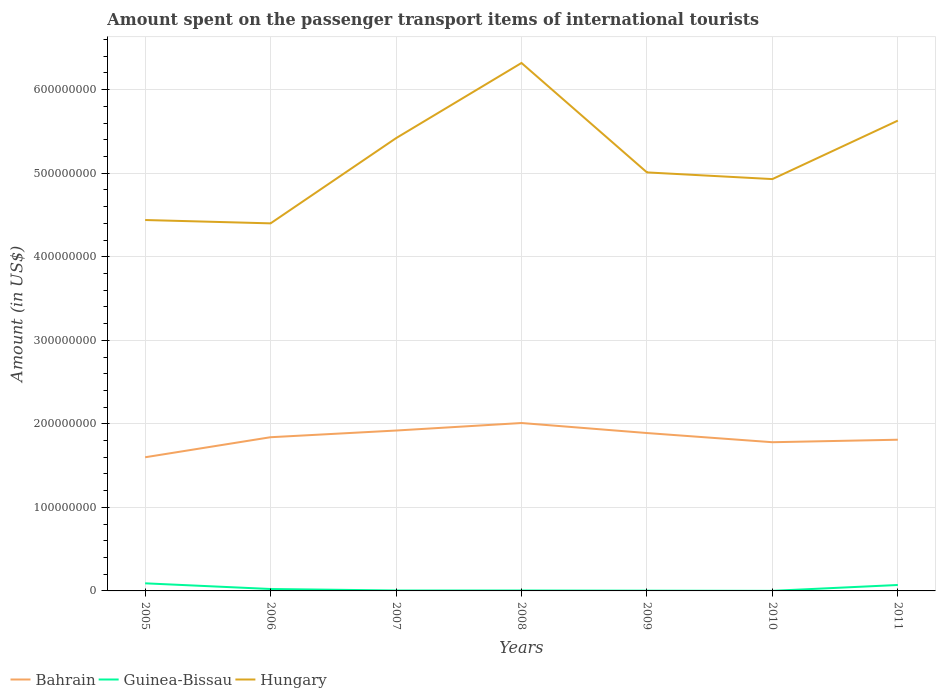How many different coloured lines are there?
Provide a short and direct response. 3. Across all years, what is the maximum amount spent on the passenger transport items of international tourists in Hungary?
Offer a terse response. 4.40e+08. In which year was the amount spent on the passenger transport items of international tourists in Hungary maximum?
Keep it short and to the point. 2006. What is the total amount spent on the passenger transport items of international tourists in Hungary in the graph?
Provide a succinct answer. -4.90e+07. What is the difference between the highest and the second highest amount spent on the passenger transport items of international tourists in Guinea-Bissau?
Provide a short and direct response. 9.00e+06. What is the difference between the highest and the lowest amount spent on the passenger transport items of international tourists in Hungary?
Offer a very short reply. 3. Are the values on the major ticks of Y-axis written in scientific E-notation?
Keep it short and to the point. No. Does the graph contain grids?
Your answer should be very brief. Yes. How many legend labels are there?
Keep it short and to the point. 3. How are the legend labels stacked?
Offer a very short reply. Horizontal. What is the title of the graph?
Provide a short and direct response. Amount spent on the passenger transport items of international tourists. Does "New Caledonia" appear as one of the legend labels in the graph?
Offer a very short reply. No. What is the label or title of the X-axis?
Give a very brief answer. Years. What is the Amount (in US$) of Bahrain in 2005?
Provide a succinct answer. 1.60e+08. What is the Amount (in US$) in Guinea-Bissau in 2005?
Offer a very short reply. 9.10e+06. What is the Amount (in US$) in Hungary in 2005?
Your response must be concise. 4.44e+08. What is the Amount (in US$) in Bahrain in 2006?
Offer a very short reply. 1.84e+08. What is the Amount (in US$) in Guinea-Bissau in 2006?
Your response must be concise. 2.30e+06. What is the Amount (in US$) in Hungary in 2006?
Provide a succinct answer. 4.40e+08. What is the Amount (in US$) in Bahrain in 2007?
Your response must be concise. 1.92e+08. What is the Amount (in US$) in Hungary in 2007?
Offer a very short reply. 5.42e+08. What is the Amount (in US$) in Bahrain in 2008?
Offer a terse response. 2.01e+08. What is the Amount (in US$) in Guinea-Bissau in 2008?
Offer a terse response. 5.00e+05. What is the Amount (in US$) of Hungary in 2008?
Give a very brief answer. 6.32e+08. What is the Amount (in US$) of Bahrain in 2009?
Provide a succinct answer. 1.89e+08. What is the Amount (in US$) in Hungary in 2009?
Your answer should be compact. 5.01e+08. What is the Amount (in US$) of Bahrain in 2010?
Ensure brevity in your answer.  1.78e+08. What is the Amount (in US$) of Guinea-Bissau in 2010?
Ensure brevity in your answer.  1.00e+05. What is the Amount (in US$) in Hungary in 2010?
Provide a succinct answer. 4.93e+08. What is the Amount (in US$) in Bahrain in 2011?
Offer a very short reply. 1.81e+08. What is the Amount (in US$) in Guinea-Bissau in 2011?
Offer a very short reply. 7.10e+06. What is the Amount (in US$) in Hungary in 2011?
Your answer should be compact. 5.63e+08. Across all years, what is the maximum Amount (in US$) in Bahrain?
Your answer should be compact. 2.01e+08. Across all years, what is the maximum Amount (in US$) in Guinea-Bissau?
Your answer should be very brief. 9.10e+06. Across all years, what is the maximum Amount (in US$) in Hungary?
Your answer should be very brief. 6.32e+08. Across all years, what is the minimum Amount (in US$) in Bahrain?
Your answer should be very brief. 1.60e+08. Across all years, what is the minimum Amount (in US$) in Hungary?
Offer a terse response. 4.40e+08. What is the total Amount (in US$) in Bahrain in the graph?
Offer a very short reply. 1.28e+09. What is the total Amount (in US$) of Guinea-Bissau in the graph?
Offer a very short reply. 1.99e+07. What is the total Amount (in US$) of Hungary in the graph?
Keep it short and to the point. 3.62e+09. What is the difference between the Amount (in US$) in Bahrain in 2005 and that in 2006?
Ensure brevity in your answer.  -2.40e+07. What is the difference between the Amount (in US$) of Guinea-Bissau in 2005 and that in 2006?
Keep it short and to the point. 6.80e+06. What is the difference between the Amount (in US$) of Hungary in 2005 and that in 2006?
Ensure brevity in your answer.  4.00e+06. What is the difference between the Amount (in US$) of Bahrain in 2005 and that in 2007?
Make the answer very short. -3.20e+07. What is the difference between the Amount (in US$) in Guinea-Bissau in 2005 and that in 2007?
Offer a very short reply. 8.60e+06. What is the difference between the Amount (in US$) in Hungary in 2005 and that in 2007?
Make the answer very short. -9.80e+07. What is the difference between the Amount (in US$) of Bahrain in 2005 and that in 2008?
Ensure brevity in your answer.  -4.10e+07. What is the difference between the Amount (in US$) of Guinea-Bissau in 2005 and that in 2008?
Offer a very short reply. 8.60e+06. What is the difference between the Amount (in US$) in Hungary in 2005 and that in 2008?
Keep it short and to the point. -1.88e+08. What is the difference between the Amount (in US$) in Bahrain in 2005 and that in 2009?
Ensure brevity in your answer.  -2.90e+07. What is the difference between the Amount (in US$) of Guinea-Bissau in 2005 and that in 2009?
Offer a terse response. 8.80e+06. What is the difference between the Amount (in US$) in Hungary in 2005 and that in 2009?
Provide a short and direct response. -5.70e+07. What is the difference between the Amount (in US$) of Bahrain in 2005 and that in 2010?
Your answer should be very brief. -1.80e+07. What is the difference between the Amount (in US$) of Guinea-Bissau in 2005 and that in 2010?
Your response must be concise. 9.00e+06. What is the difference between the Amount (in US$) of Hungary in 2005 and that in 2010?
Provide a succinct answer. -4.90e+07. What is the difference between the Amount (in US$) in Bahrain in 2005 and that in 2011?
Ensure brevity in your answer.  -2.10e+07. What is the difference between the Amount (in US$) of Hungary in 2005 and that in 2011?
Keep it short and to the point. -1.19e+08. What is the difference between the Amount (in US$) in Bahrain in 2006 and that in 2007?
Offer a very short reply. -8.00e+06. What is the difference between the Amount (in US$) in Guinea-Bissau in 2006 and that in 2007?
Your answer should be compact. 1.80e+06. What is the difference between the Amount (in US$) in Hungary in 2006 and that in 2007?
Provide a short and direct response. -1.02e+08. What is the difference between the Amount (in US$) in Bahrain in 2006 and that in 2008?
Offer a terse response. -1.70e+07. What is the difference between the Amount (in US$) in Guinea-Bissau in 2006 and that in 2008?
Offer a very short reply. 1.80e+06. What is the difference between the Amount (in US$) of Hungary in 2006 and that in 2008?
Provide a succinct answer. -1.92e+08. What is the difference between the Amount (in US$) of Bahrain in 2006 and that in 2009?
Offer a very short reply. -5.00e+06. What is the difference between the Amount (in US$) of Guinea-Bissau in 2006 and that in 2009?
Give a very brief answer. 2.00e+06. What is the difference between the Amount (in US$) of Hungary in 2006 and that in 2009?
Offer a terse response. -6.10e+07. What is the difference between the Amount (in US$) of Bahrain in 2006 and that in 2010?
Keep it short and to the point. 6.00e+06. What is the difference between the Amount (in US$) in Guinea-Bissau in 2006 and that in 2010?
Provide a short and direct response. 2.20e+06. What is the difference between the Amount (in US$) in Hungary in 2006 and that in 2010?
Make the answer very short. -5.30e+07. What is the difference between the Amount (in US$) in Bahrain in 2006 and that in 2011?
Make the answer very short. 3.00e+06. What is the difference between the Amount (in US$) of Guinea-Bissau in 2006 and that in 2011?
Ensure brevity in your answer.  -4.80e+06. What is the difference between the Amount (in US$) in Hungary in 2006 and that in 2011?
Your answer should be compact. -1.23e+08. What is the difference between the Amount (in US$) in Bahrain in 2007 and that in 2008?
Your response must be concise. -9.00e+06. What is the difference between the Amount (in US$) of Hungary in 2007 and that in 2008?
Your answer should be compact. -9.00e+07. What is the difference between the Amount (in US$) of Guinea-Bissau in 2007 and that in 2009?
Keep it short and to the point. 2.00e+05. What is the difference between the Amount (in US$) in Hungary in 2007 and that in 2009?
Your answer should be very brief. 4.10e+07. What is the difference between the Amount (in US$) in Bahrain in 2007 and that in 2010?
Offer a very short reply. 1.40e+07. What is the difference between the Amount (in US$) of Hungary in 2007 and that in 2010?
Make the answer very short. 4.90e+07. What is the difference between the Amount (in US$) of Bahrain in 2007 and that in 2011?
Give a very brief answer. 1.10e+07. What is the difference between the Amount (in US$) of Guinea-Bissau in 2007 and that in 2011?
Provide a succinct answer. -6.60e+06. What is the difference between the Amount (in US$) in Hungary in 2007 and that in 2011?
Your response must be concise. -2.10e+07. What is the difference between the Amount (in US$) in Guinea-Bissau in 2008 and that in 2009?
Your answer should be very brief. 2.00e+05. What is the difference between the Amount (in US$) in Hungary in 2008 and that in 2009?
Offer a terse response. 1.31e+08. What is the difference between the Amount (in US$) of Bahrain in 2008 and that in 2010?
Offer a very short reply. 2.30e+07. What is the difference between the Amount (in US$) of Guinea-Bissau in 2008 and that in 2010?
Ensure brevity in your answer.  4.00e+05. What is the difference between the Amount (in US$) of Hungary in 2008 and that in 2010?
Your answer should be compact. 1.39e+08. What is the difference between the Amount (in US$) in Guinea-Bissau in 2008 and that in 2011?
Ensure brevity in your answer.  -6.60e+06. What is the difference between the Amount (in US$) in Hungary in 2008 and that in 2011?
Your response must be concise. 6.90e+07. What is the difference between the Amount (in US$) in Bahrain in 2009 and that in 2010?
Keep it short and to the point. 1.10e+07. What is the difference between the Amount (in US$) of Guinea-Bissau in 2009 and that in 2011?
Provide a short and direct response. -6.80e+06. What is the difference between the Amount (in US$) of Hungary in 2009 and that in 2011?
Offer a very short reply. -6.20e+07. What is the difference between the Amount (in US$) of Bahrain in 2010 and that in 2011?
Your response must be concise. -3.00e+06. What is the difference between the Amount (in US$) in Guinea-Bissau in 2010 and that in 2011?
Your answer should be compact. -7.00e+06. What is the difference between the Amount (in US$) in Hungary in 2010 and that in 2011?
Offer a very short reply. -7.00e+07. What is the difference between the Amount (in US$) in Bahrain in 2005 and the Amount (in US$) in Guinea-Bissau in 2006?
Your response must be concise. 1.58e+08. What is the difference between the Amount (in US$) in Bahrain in 2005 and the Amount (in US$) in Hungary in 2006?
Make the answer very short. -2.80e+08. What is the difference between the Amount (in US$) of Guinea-Bissau in 2005 and the Amount (in US$) of Hungary in 2006?
Ensure brevity in your answer.  -4.31e+08. What is the difference between the Amount (in US$) in Bahrain in 2005 and the Amount (in US$) in Guinea-Bissau in 2007?
Keep it short and to the point. 1.60e+08. What is the difference between the Amount (in US$) in Bahrain in 2005 and the Amount (in US$) in Hungary in 2007?
Make the answer very short. -3.82e+08. What is the difference between the Amount (in US$) in Guinea-Bissau in 2005 and the Amount (in US$) in Hungary in 2007?
Offer a very short reply. -5.33e+08. What is the difference between the Amount (in US$) in Bahrain in 2005 and the Amount (in US$) in Guinea-Bissau in 2008?
Offer a very short reply. 1.60e+08. What is the difference between the Amount (in US$) of Bahrain in 2005 and the Amount (in US$) of Hungary in 2008?
Offer a terse response. -4.72e+08. What is the difference between the Amount (in US$) in Guinea-Bissau in 2005 and the Amount (in US$) in Hungary in 2008?
Keep it short and to the point. -6.23e+08. What is the difference between the Amount (in US$) of Bahrain in 2005 and the Amount (in US$) of Guinea-Bissau in 2009?
Your answer should be very brief. 1.60e+08. What is the difference between the Amount (in US$) of Bahrain in 2005 and the Amount (in US$) of Hungary in 2009?
Give a very brief answer. -3.41e+08. What is the difference between the Amount (in US$) of Guinea-Bissau in 2005 and the Amount (in US$) of Hungary in 2009?
Provide a succinct answer. -4.92e+08. What is the difference between the Amount (in US$) of Bahrain in 2005 and the Amount (in US$) of Guinea-Bissau in 2010?
Offer a terse response. 1.60e+08. What is the difference between the Amount (in US$) of Bahrain in 2005 and the Amount (in US$) of Hungary in 2010?
Offer a very short reply. -3.33e+08. What is the difference between the Amount (in US$) in Guinea-Bissau in 2005 and the Amount (in US$) in Hungary in 2010?
Your answer should be compact. -4.84e+08. What is the difference between the Amount (in US$) of Bahrain in 2005 and the Amount (in US$) of Guinea-Bissau in 2011?
Provide a short and direct response. 1.53e+08. What is the difference between the Amount (in US$) in Bahrain in 2005 and the Amount (in US$) in Hungary in 2011?
Provide a succinct answer. -4.03e+08. What is the difference between the Amount (in US$) in Guinea-Bissau in 2005 and the Amount (in US$) in Hungary in 2011?
Ensure brevity in your answer.  -5.54e+08. What is the difference between the Amount (in US$) in Bahrain in 2006 and the Amount (in US$) in Guinea-Bissau in 2007?
Provide a succinct answer. 1.84e+08. What is the difference between the Amount (in US$) in Bahrain in 2006 and the Amount (in US$) in Hungary in 2007?
Offer a terse response. -3.58e+08. What is the difference between the Amount (in US$) in Guinea-Bissau in 2006 and the Amount (in US$) in Hungary in 2007?
Keep it short and to the point. -5.40e+08. What is the difference between the Amount (in US$) of Bahrain in 2006 and the Amount (in US$) of Guinea-Bissau in 2008?
Make the answer very short. 1.84e+08. What is the difference between the Amount (in US$) of Bahrain in 2006 and the Amount (in US$) of Hungary in 2008?
Your answer should be very brief. -4.48e+08. What is the difference between the Amount (in US$) of Guinea-Bissau in 2006 and the Amount (in US$) of Hungary in 2008?
Offer a terse response. -6.30e+08. What is the difference between the Amount (in US$) of Bahrain in 2006 and the Amount (in US$) of Guinea-Bissau in 2009?
Ensure brevity in your answer.  1.84e+08. What is the difference between the Amount (in US$) in Bahrain in 2006 and the Amount (in US$) in Hungary in 2009?
Offer a terse response. -3.17e+08. What is the difference between the Amount (in US$) in Guinea-Bissau in 2006 and the Amount (in US$) in Hungary in 2009?
Offer a very short reply. -4.99e+08. What is the difference between the Amount (in US$) of Bahrain in 2006 and the Amount (in US$) of Guinea-Bissau in 2010?
Provide a short and direct response. 1.84e+08. What is the difference between the Amount (in US$) in Bahrain in 2006 and the Amount (in US$) in Hungary in 2010?
Your answer should be compact. -3.09e+08. What is the difference between the Amount (in US$) in Guinea-Bissau in 2006 and the Amount (in US$) in Hungary in 2010?
Keep it short and to the point. -4.91e+08. What is the difference between the Amount (in US$) in Bahrain in 2006 and the Amount (in US$) in Guinea-Bissau in 2011?
Your answer should be compact. 1.77e+08. What is the difference between the Amount (in US$) in Bahrain in 2006 and the Amount (in US$) in Hungary in 2011?
Provide a succinct answer. -3.79e+08. What is the difference between the Amount (in US$) of Guinea-Bissau in 2006 and the Amount (in US$) of Hungary in 2011?
Provide a short and direct response. -5.61e+08. What is the difference between the Amount (in US$) in Bahrain in 2007 and the Amount (in US$) in Guinea-Bissau in 2008?
Offer a very short reply. 1.92e+08. What is the difference between the Amount (in US$) of Bahrain in 2007 and the Amount (in US$) of Hungary in 2008?
Keep it short and to the point. -4.40e+08. What is the difference between the Amount (in US$) of Guinea-Bissau in 2007 and the Amount (in US$) of Hungary in 2008?
Offer a very short reply. -6.32e+08. What is the difference between the Amount (in US$) of Bahrain in 2007 and the Amount (in US$) of Guinea-Bissau in 2009?
Provide a succinct answer. 1.92e+08. What is the difference between the Amount (in US$) in Bahrain in 2007 and the Amount (in US$) in Hungary in 2009?
Make the answer very short. -3.09e+08. What is the difference between the Amount (in US$) of Guinea-Bissau in 2007 and the Amount (in US$) of Hungary in 2009?
Your answer should be very brief. -5.00e+08. What is the difference between the Amount (in US$) in Bahrain in 2007 and the Amount (in US$) in Guinea-Bissau in 2010?
Ensure brevity in your answer.  1.92e+08. What is the difference between the Amount (in US$) of Bahrain in 2007 and the Amount (in US$) of Hungary in 2010?
Make the answer very short. -3.01e+08. What is the difference between the Amount (in US$) of Guinea-Bissau in 2007 and the Amount (in US$) of Hungary in 2010?
Your answer should be very brief. -4.92e+08. What is the difference between the Amount (in US$) of Bahrain in 2007 and the Amount (in US$) of Guinea-Bissau in 2011?
Keep it short and to the point. 1.85e+08. What is the difference between the Amount (in US$) in Bahrain in 2007 and the Amount (in US$) in Hungary in 2011?
Make the answer very short. -3.71e+08. What is the difference between the Amount (in US$) of Guinea-Bissau in 2007 and the Amount (in US$) of Hungary in 2011?
Your answer should be compact. -5.62e+08. What is the difference between the Amount (in US$) in Bahrain in 2008 and the Amount (in US$) in Guinea-Bissau in 2009?
Make the answer very short. 2.01e+08. What is the difference between the Amount (in US$) in Bahrain in 2008 and the Amount (in US$) in Hungary in 2009?
Offer a very short reply. -3.00e+08. What is the difference between the Amount (in US$) in Guinea-Bissau in 2008 and the Amount (in US$) in Hungary in 2009?
Give a very brief answer. -5.00e+08. What is the difference between the Amount (in US$) in Bahrain in 2008 and the Amount (in US$) in Guinea-Bissau in 2010?
Give a very brief answer. 2.01e+08. What is the difference between the Amount (in US$) in Bahrain in 2008 and the Amount (in US$) in Hungary in 2010?
Offer a terse response. -2.92e+08. What is the difference between the Amount (in US$) in Guinea-Bissau in 2008 and the Amount (in US$) in Hungary in 2010?
Your answer should be compact. -4.92e+08. What is the difference between the Amount (in US$) in Bahrain in 2008 and the Amount (in US$) in Guinea-Bissau in 2011?
Your answer should be compact. 1.94e+08. What is the difference between the Amount (in US$) in Bahrain in 2008 and the Amount (in US$) in Hungary in 2011?
Keep it short and to the point. -3.62e+08. What is the difference between the Amount (in US$) of Guinea-Bissau in 2008 and the Amount (in US$) of Hungary in 2011?
Offer a terse response. -5.62e+08. What is the difference between the Amount (in US$) of Bahrain in 2009 and the Amount (in US$) of Guinea-Bissau in 2010?
Your answer should be very brief. 1.89e+08. What is the difference between the Amount (in US$) of Bahrain in 2009 and the Amount (in US$) of Hungary in 2010?
Ensure brevity in your answer.  -3.04e+08. What is the difference between the Amount (in US$) of Guinea-Bissau in 2009 and the Amount (in US$) of Hungary in 2010?
Your answer should be compact. -4.93e+08. What is the difference between the Amount (in US$) in Bahrain in 2009 and the Amount (in US$) in Guinea-Bissau in 2011?
Offer a very short reply. 1.82e+08. What is the difference between the Amount (in US$) of Bahrain in 2009 and the Amount (in US$) of Hungary in 2011?
Give a very brief answer. -3.74e+08. What is the difference between the Amount (in US$) of Guinea-Bissau in 2009 and the Amount (in US$) of Hungary in 2011?
Provide a succinct answer. -5.63e+08. What is the difference between the Amount (in US$) of Bahrain in 2010 and the Amount (in US$) of Guinea-Bissau in 2011?
Keep it short and to the point. 1.71e+08. What is the difference between the Amount (in US$) of Bahrain in 2010 and the Amount (in US$) of Hungary in 2011?
Make the answer very short. -3.85e+08. What is the difference between the Amount (in US$) of Guinea-Bissau in 2010 and the Amount (in US$) of Hungary in 2011?
Ensure brevity in your answer.  -5.63e+08. What is the average Amount (in US$) of Bahrain per year?
Make the answer very short. 1.84e+08. What is the average Amount (in US$) in Guinea-Bissau per year?
Provide a succinct answer. 2.84e+06. What is the average Amount (in US$) of Hungary per year?
Your response must be concise. 5.16e+08. In the year 2005, what is the difference between the Amount (in US$) in Bahrain and Amount (in US$) in Guinea-Bissau?
Your answer should be very brief. 1.51e+08. In the year 2005, what is the difference between the Amount (in US$) in Bahrain and Amount (in US$) in Hungary?
Keep it short and to the point. -2.84e+08. In the year 2005, what is the difference between the Amount (in US$) in Guinea-Bissau and Amount (in US$) in Hungary?
Give a very brief answer. -4.35e+08. In the year 2006, what is the difference between the Amount (in US$) in Bahrain and Amount (in US$) in Guinea-Bissau?
Your response must be concise. 1.82e+08. In the year 2006, what is the difference between the Amount (in US$) of Bahrain and Amount (in US$) of Hungary?
Offer a very short reply. -2.56e+08. In the year 2006, what is the difference between the Amount (in US$) in Guinea-Bissau and Amount (in US$) in Hungary?
Your answer should be compact. -4.38e+08. In the year 2007, what is the difference between the Amount (in US$) of Bahrain and Amount (in US$) of Guinea-Bissau?
Provide a succinct answer. 1.92e+08. In the year 2007, what is the difference between the Amount (in US$) of Bahrain and Amount (in US$) of Hungary?
Your answer should be very brief. -3.50e+08. In the year 2007, what is the difference between the Amount (in US$) of Guinea-Bissau and Amount (in US$) of Hungary?
Your response must be concise. -5.42e+08. In the year 2008, what is the difference between the Amount (in US$) in Bahrain and Amount (in US$) in Guinea-Bissau?
Make the answer very short. 2.00e+08. In the year 2008, what is the difference between the Amount (in US$) in Bahrain and Amount (in US$) in Hungary?
Offer a terse response. -4.31e+08. In the year 2008, what is the difference between the Amount (in US$) of Guinea-Bissau and Amount (in US$) of Hungary?
Make the answer very short. -6.32e+08. In the year 2009, what is the difference between the Amount (in US$) of Bahrain and Amount (in US$) of Guinea-Bissau?
Give a very brief answer. 1.89e+08. In the year 2009, what is the difference between the Amount (in US$) in Bahrain and Amount (in US$) in Hungary?
Make the answer very short. -3.12e+08. In the year 2009, what is the difference between the Amount (in US$) of Guinea-Bissau and Amount (in US$) of Hungary?
Provide a short and direct response. -5.01e+08. In the year 2010, what is the difference between the Amount (in US$) in Bahrain and Amount (in US$) in Guinea-Bissau?
Your answer should be compact. 1.78e+08. In the year 2010, what is the difference between the Amount (in US$) in Bahrain and Amount (in US$) in Hungary?
Your response must be concise. -3.15e+08. In the year 2010, what is the difference between the Amount (in US$) of Guinea-Bissau and Amount (in US$) of Hungary?
Your response must be concise. -4.93e+08. In the year 2011, what is the difference between the Amount (in US$) of Bahrain and Amount (in US$) of Guinea-Bissau?
Provide a succinct answer. 1.74e+08. In the year 2011, what is the difference between the Amount (in US$) of Bahrain and Amount (in US$) of Hungary?
Offer a very short reply. -3.82e+08. In the year 2011, what is the difference between the Amount (in US$) in Guinea-Bissau and Amount (in US$) in Hungary?
Give a very brief answer. -5.56e+08. What is the ratio of the Amount (in US$) of Bahrain in 2005 to that in 2006?
Your answer should be very brief. 0.87. What is the ratio of the Amount (in US$) of Guinea-Bissau in 2005 to that in 2006?
Keep it short and to the point. 3.96. What is the ratio of the Amount (in US$) of Hungary in 2005 to that in 2006?
Your answer should be very brief. 1.01. What is the ratio of the Amount (in US$) of Guinea-Bissau in 2005 to that in 2007?
Your response must be concise. 18.2. What is the ratio of the Amount (in US$) in Hungary in 2005 to that in 2007?
Offer a terse response. 0.82. What is the ratio of the Amount (in US$) of Bahrain in 2005 to that in 2008?
Offer a very short reply. 0.8. What is the ratio of the Amount (in US$) in Guinea-Bissau in 2005 to that in 2008?
Give a very brief answer. 18.2. What is the ratio of the Amount (in US$) in Hungary in 2005 to that in 2008?
Give a very brief answer. 0.7. What is the ratio of the Amount (in US$) in Bahrain in 2005 to that in 2009?
Offer a terse response. 0.85. What is the ratio of the Amount (in US$) in Guinea-Bissau in 2005 to that in 2009?
Provide a succinct answer. 30.33. What is the ratio of the Amount (in US$) in Hungary in 2005 to that in 2009?
Offer a very short reply. 0.89. What is the ratio of the Amount (in US$) in Bahrain in 2005 to that in 2010?
Your response must be concise. 0.9. What is the ratio of the Amount (in US$) of Guinea-Bissau in 2005 to that in 2010?
Make the answer very short. 91. What is the ratio of the Amount (in US$) in Hungary in 2005 to that in 2010?
Offer a terse response. 0.9. What is the ratio of the Amount (in US$) in Bahrain in 2005 to that in 2011?
Your answer should be very brief. 0.88. What is the ratio of the Amount (in US$) in Guinea-Bissau in 2005 to that in 2011?
Ensure brevity in your answer.  1.28. What is the ratio of the Amount (in US$) of Hungary in 2005 to that in 2011?
Give a very brief answer. 0.79. What is the ratio of the Amount (in US$) of Guinea-Bissau in 2006 to that in 2007?
Offer a terse response. 4.6. What is the ratio of the Amount (in US$) of Hungary in 2006 to that in 2007?
Your answer should be compact. 0.81. What is the ratio of the Amount (in US$) in Bahrain in 2006 to that in 2008?
Offer a terse response. 0.92. What is the ratio of the Amount (in US$) of Guinea-Bissau in 2006 to that in 2008?
Keep it short and to the point. 4.6. What is the ratio of the Amount (in US$) in Hungary in 2006 to that in 2008?
Offer a terse response. 0.7. What is the ratio of the Amount (in US$) of Bahrain in 2006 to that in 2009?
Make the answer very short. 0.97. What is the ratio of the Amount (in US$) of Guinea-Bissau in 2006 to that in 2009?
Provide a succinct answer. 7.67. What is the ratio of the Amount (in US$) in Hungary in 2006 to that in 2009?
Give a very brief answer. 0.88. What is the ratio of the Amount (in US$) in Bahrain in 2006 to that in 2010?
Your response must be concise. 1.03. What is the ratio of the Amount (in US$) of Guinea-Bissau in 2006 to that in 2010?
Offer a terse response. 23. What is the ratio of the Amount (in US$) in Hungary in 2006 to that in 2010?
Provide a short and direct response. 0.89. What is the ratio of the Amount (in US$) in Bahrain in 2006 to that in 2011?
Keep it short and to the point. 1.02. What is the ratio of the Amount (in US$) in Guinea-Bissau in 2006 to that in 2011?
Your answer should be very brief. 0.32. What is the ratio of the Amount (in US$) in Hungary in 2006 to that in 2011?
Give a very brief answer. 0.78. What is the ratio of the Amount (in US$) of Bahrain in 2007 to that in 2008?
Give a very brief answer. 0.96. What is the ratio of the Amount (in US$) in Hungary in 2007 to that in 2008?
Keep it short and to the point. 0.86. What is the ratio of the Amount (in US$) of Bahrain in 2007 to that in 2009?
Ensure brevity in your answer.  1.02. What is the ratio of the Amount (in US$) in Guinea-Bissau in 2007 to that in 2009?
Your response must be concise. 1.67. What is the ratio of the Amount (in US$) of Hungary in 2007 to that in 2009?
Offer a very short reply. 1.08. What is the ratio of the Amount (in US$) in Bahrain in 2007 to that in 2010?
Your answer should be very brief. 1.08. What is the ratio of the Amount (in US$) in Hungary in 2007 to that in 2010?
Provide a short and direct response. 1.1. What is the ratio of the Amount (in US$) in Bahrain in 2007 to that in 2011?
Your response must be concise. 1.06. What is the ratio of the Amount (in US$) in Guinea-Bissau in 2007 to that in 2011?
Keep it short and to the point. 0.07. What is the ratio of the Amount (in US$) in Hungary in 2007 to that in 2011?
Offer a terse response. 0.96. What is the ratio of the Amount (in US$) of Bahrain in 2008 to that in 2009?
Offer a terse response. 1.06. What is the ratio of the Amount (in US$) of Guinea-Bissau in 2008 to that in 2009?
Provide a short and direct response. 1.67. What is the ratio of the Amount (in US$) of Hungary in 2008 to that in 2009?
Provide a short and direct response. 1.26. What is the ratio of the Amount (in US$) in Bahrain in 2008 to that in 2010?
Offer a terse response. 1.13. What is the ratio of the Amount (in US$) of Hungary in 2008 to that in 2010?
Offer a very short reply. 1.28. What is the ratio of the Amount (in US$) in Bahrain in 2008 to that in 2011?
Offer a terse response. 1.11. What is the ratio of the Amount (in US$) in Guinea-Bissau in 2008 to that in 2011?
Your response must be concise. 0.07. What is the ratio of the Amount (in US$) in Hungary in 2008 to that in 2011?
Your response must be concise. 1.12. What is the ratio of the Amount (in US$) in Bahrain in 2009 to that in 2010?
Your response must be concise. 1.06. What is the ratio of the Amount (in US$) in Guinea-Bissau in 2009 to that in 2010?
Provide a short and direct response. 3. What is the ratio of the Amount (in US$) of Hungary in 2009 to that in 2010?
Your response must be concise. 1.02. What is the ratio of the Amount (in US$) of Bahrain in 2009 to that in 2011?
Offer a very short reply. 1.04. What is the ratio of the Amount (in US$) of Guinea-Bissau in 2009 to that in 2011?
Make the answer very short. 0.04. What is the ratio of the Amount (in US$) of Hungary in 2009 to that in 2011?
Provide a succinct answer. 0.89. What is the ratio of the Amount (in US$) in Bahrain in 2010 to that in 2011?
Give a very brief answer. 0.98. What is the ratio of the Amount (in US$) in Guinea-Bissau in 2010 to that in 2011?
Make the answer very short. 0.01. What is the ratio of the Amount (in US$) in Hungary in 2010 to that in 2011?
Provide a succinct answer. 0.88. What is the difference between the highest and the second highest Amount (in US$) in Bahrain?
Keep it short and to the point. 9.00e+06. What is the difference between the highest and the second highest Amount (in US$) of Guinea-Bissau?
Offer a very short reply. 2.00e+06. What is the difference between the highest and the second highest Amount (in US$) in Hungary?
Offer a terse response. 6.90e+07. What is the difference between the highest and the lowest Amount (in US$) in Bahrain?
Provide a short and direct response. 4.10e+07. What is the difference between the highest and the lowest Amount (in US$) in Guinea-Bissau?
Offer a terse response. 9.00e+06. What is the difference between the highest and the lowest Amount (in US$) of Hungary?
Provide a succinct answer. 1.92e+08. 